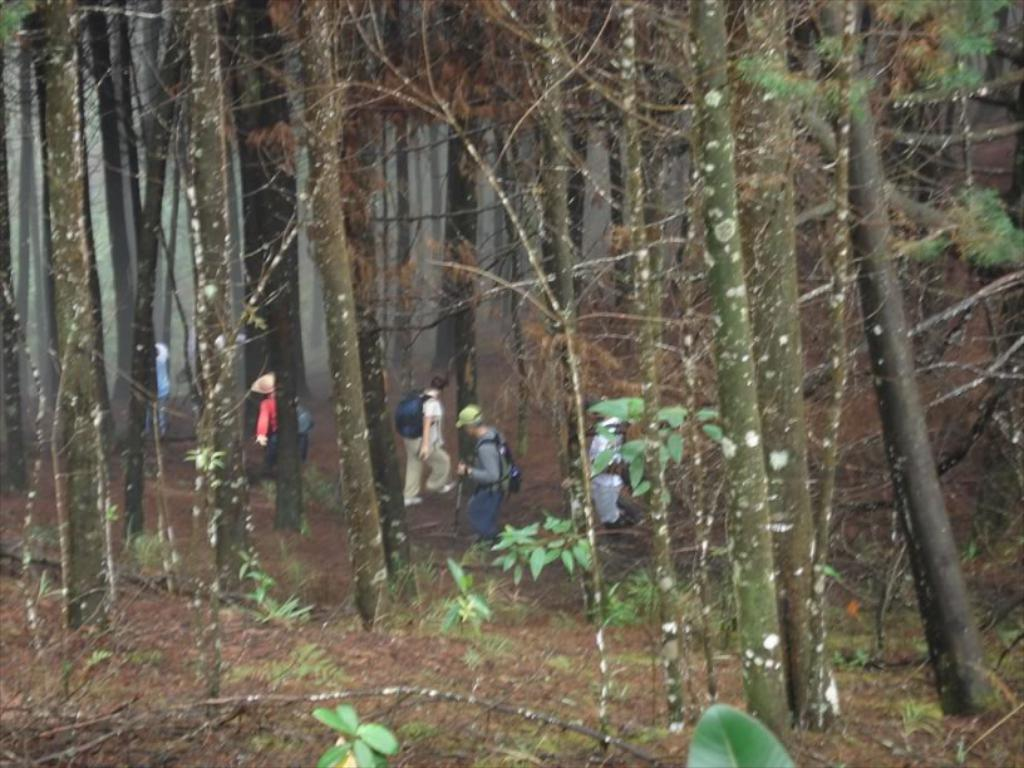What type of vegetation can be seen in the image? There are trees in the image. What is the group of people doing in the image? The people are walking on the land between the trees. What songs are being sung by the trees in the image? Trees do not sing songs, so there are no songs being sung by the trees in the image. 